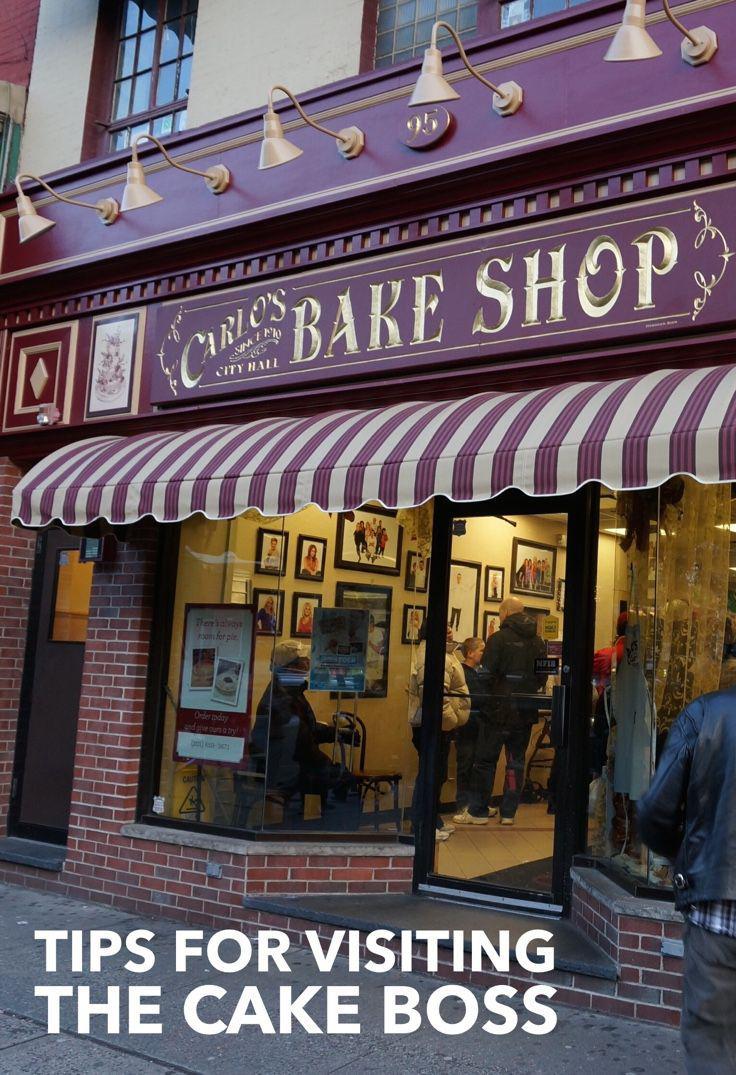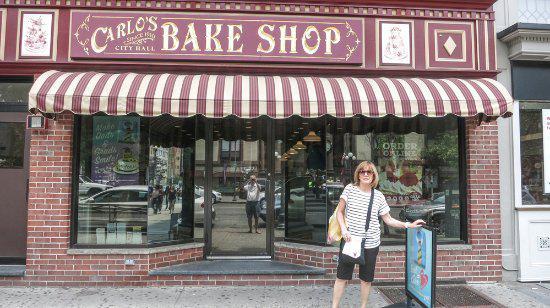The first image is the image on the left, the second image is the image on the right. Given the left and right images, does the statement "There is at least one person standing outside the store in the image on the right." hold true? Answer yes or no. Yes. 